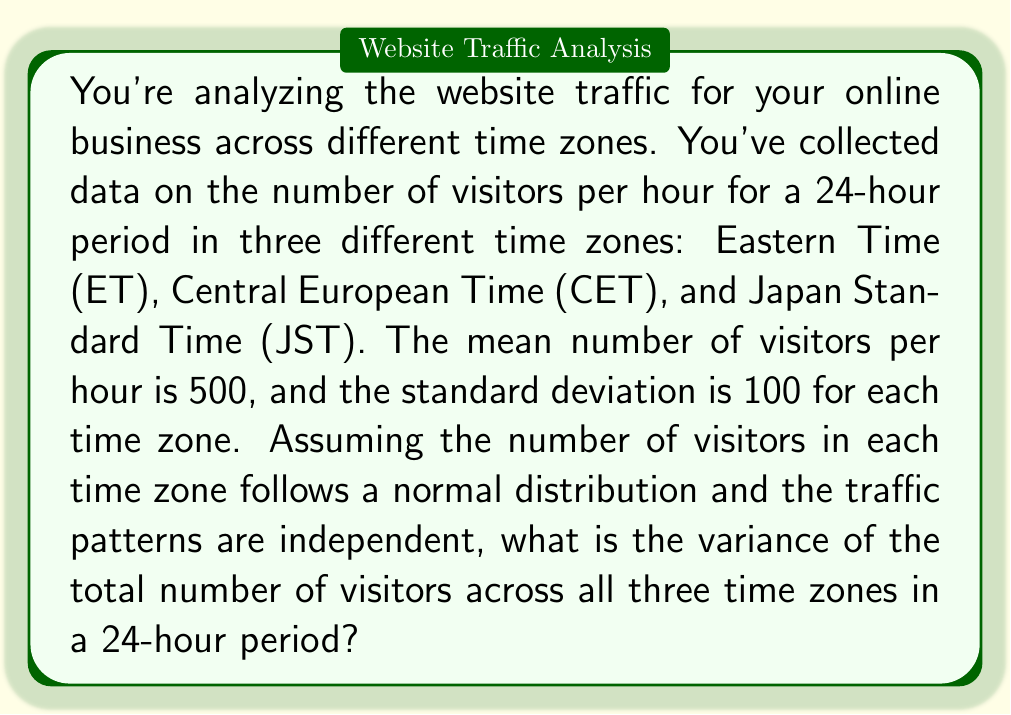Could you help me with this problem? Let's approach this step-by-step:

1) First, let's define our random variables:
   Let $X_1$, $X_2$, and $X_3$ represent the number of visitors in a 24-hour period for ET, CET, and JST respectively.

2) We're given that for each time zone:
   - Mean (μ) = 500 visitors per hour
   - Standard deviation (σ) = 100 visitors per hour

3) For a 24-hour period, we need to multiply these values by 24:
   - Mean for 24 hours: $\mu_{24} = 500 * 24 = 12000$ visitors
   - Variance for 24 hours: $\sigma^2_{24} = (100^2) * 24 = 240000$ visitors^2

4) Now, we want to find the variance of the total visitors across all three time zones.
   Let $Y = X_1 + X_2 + X_3$ be the total number of visitors.

5) Given that the traffic patterns are independent, we can use the property of variance for independent random variables:
   $Var(aX + bY) = a^2Var(X) + b^2Var(Y)$

6) In our case, this becomes:
   $Var(Y) = Var(X_1 + X_2 + X_3) = Var(X_1) + Var(X_2) + Var(X_3)$

7) Since each time zone has the same variance:
   $Var(Y) = 240000 + 240000 + 240000 = 720000$ visitors^2

Therefore, the variance of the total number of visitors across all three time zones in a 24-hour period is 720000 visitors^2.
Answer: 720000 visitors^2 